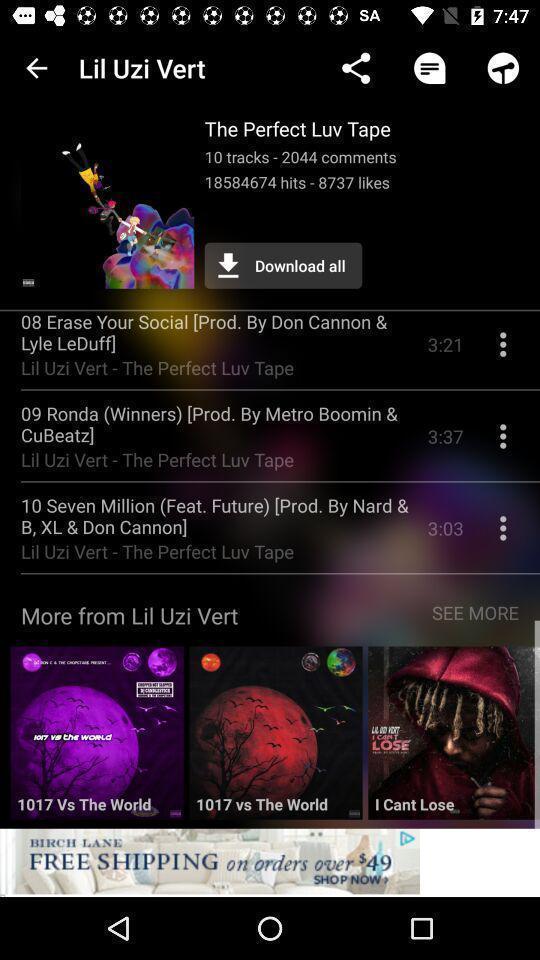Explain what's happening in this screen capture. Screen page displaying various tracks in music application. 